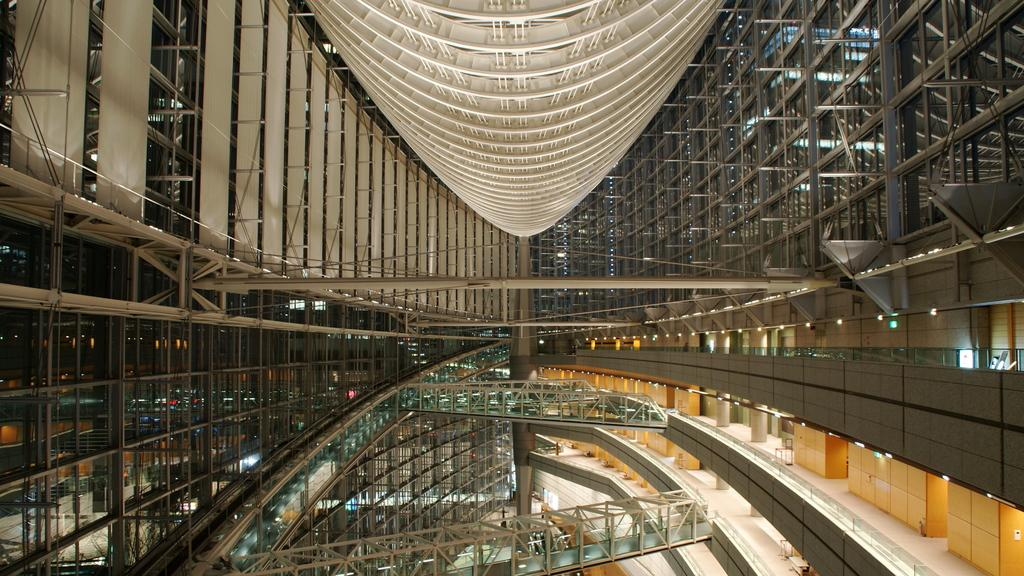What type of location is depicted in the image? The image is an inside view of a mall. What type of ball can be seen in the image? There is no ball present in the image; it is an inside view of a mall. What type of letters can be seen in the image? There is no reference to letters in the image, as it is an inside view of a mall. What type of jar can be seen in the image? There is no jar present in the image; it is an inside view of a mall. 